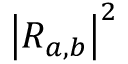<formula> <loc_0><loc_0><loc_500><loc_500>{ \left | R _ { a , b } \right | } ^ { 2 }</formula> 